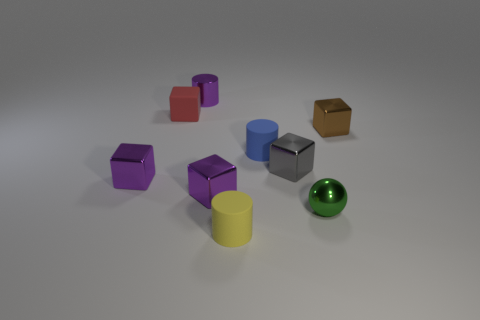Are there any objects in front of the gray shiny object?
Offer a terse response. Yes. There is a small blue thing; what shape is it?
Keep it short and to the point. Cylinder. There is a small metal object that is in front of the purple thing right of the small cylinder that is behind the blue rubber thing; what shape is it?
Your answer should be very brief. Sphere. What number of other things are there of the same shape as the tiny red thing?
Make the answer very short. 4. What material is the cylinder that is in front of the tiny matte cylinder that is behind the tiny green sphere made of?
Keep it short and to the point. Rubber. Is the material of the blue cylinder the same as the cylinder that is in front of the metal ball?
Keep it short and to the point. Yes. What material is the cylinder that is to the left of the tiny blue matte cylinder and behind the yellow matte thing?
Your response must be concise. Metal. The cylinder behind the tiny cube that is right of the shiny sphere is what color?
Your answer should be very brief. Purple. What is the purple thing behind the brown shiny object made of?
Your answer should be very brief. Metal. Are there fewer small green balls than big blue cylinders?
Keep it short and to the point. No. 